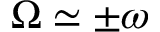<formula> <loc_0><loc_0><loc_500><loc_500>\Omega \simeq \pm \omega</formula> 